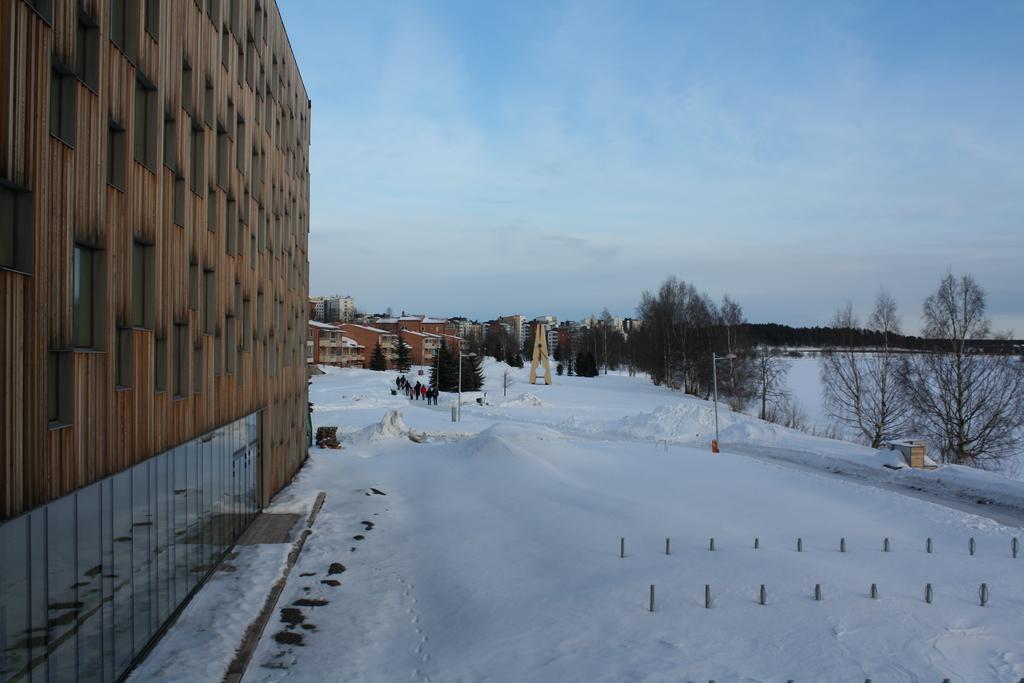Can you describe this image briefly? In this image, there are a few buildings, people, trees, poles. We can see the ground covered with snow and some objects. We can also see some plants. We can see some glass and the reflection of the ground is seen in the glass. 